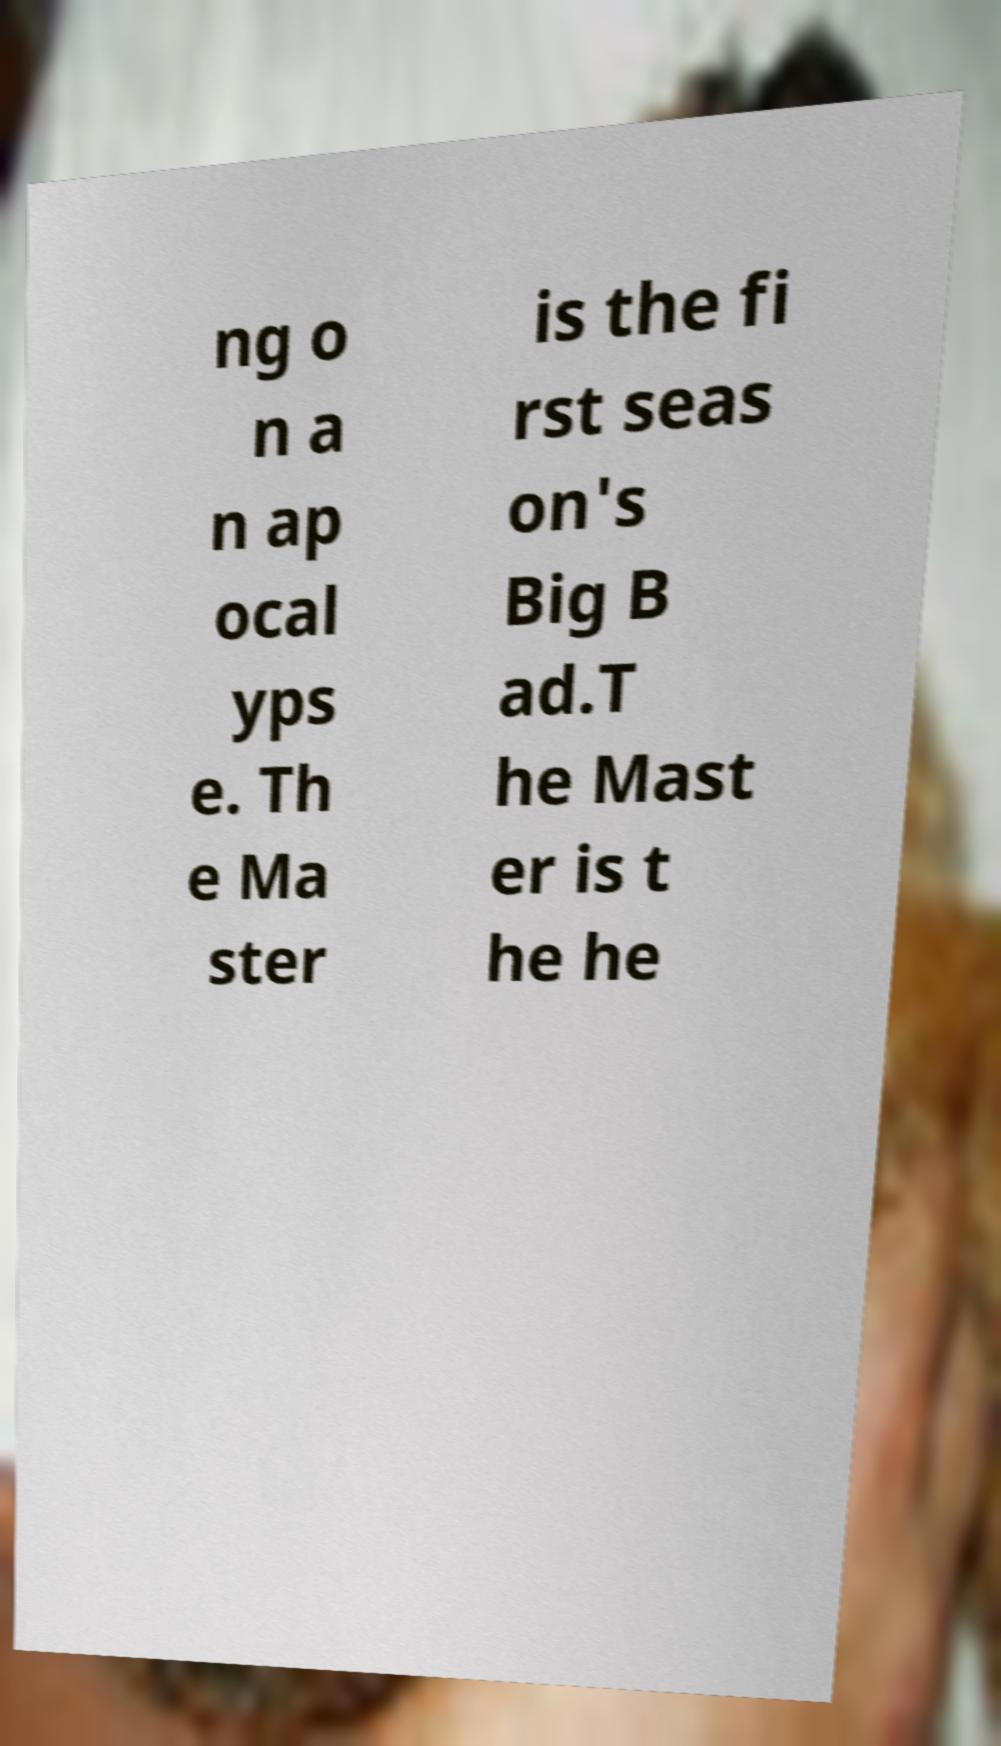Please read and relay the text visible in this image. What does it say? ng o n a n ap ocal yps e. Th e Ma ster is the fi rst seas on's Big B ad.T he Mast er is t he he 